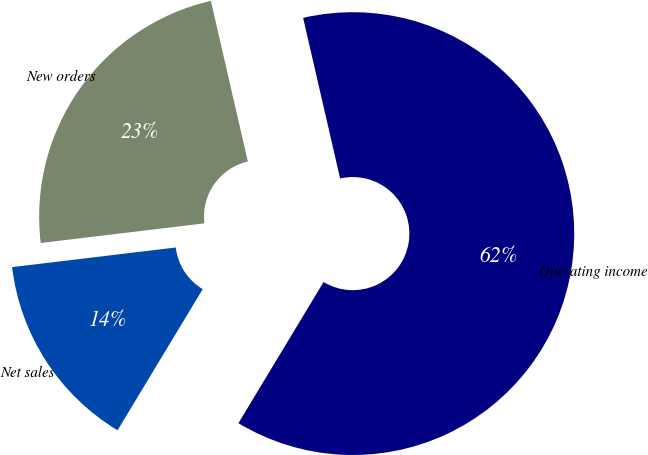Convert chart to OTSL. <chart><loc_0><loc_0><loc_500><loc_500><pie_chart><fcel>New orders<fcel>Net sales<fcel>Operating income<nl><fcel>23.3%<fcel>14.46%<fcel>62.25%<nl></chart> 